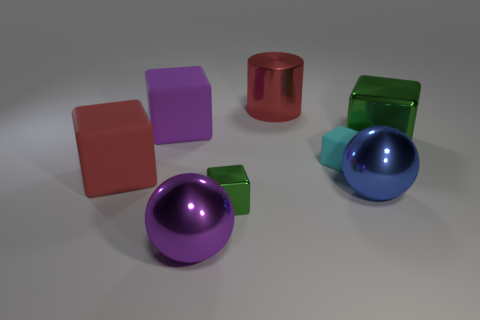Can you describe the colors and shapes of the objects in the image? Certainly! The image features a collection of geometric objects. There are two spheres with shiny surfaces, one purple and one blue. There are also four cubes in various colors: purple, red, green, and small cyan. Additionally, there's one red cylindrical object with a metallic finish. 